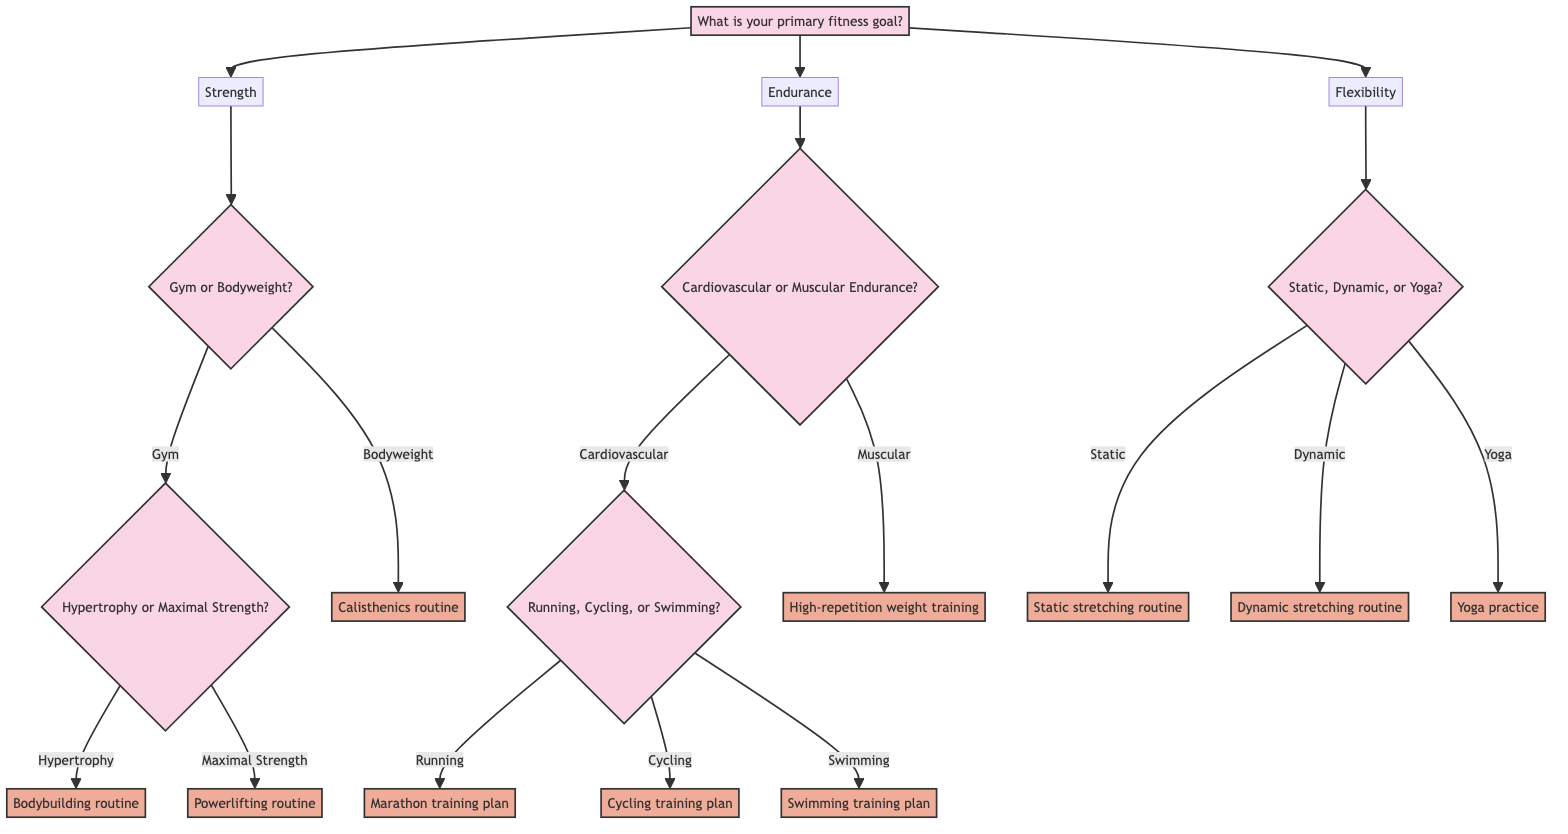What is the first question in the diagram? The first question in the diagram is presented at the root node, asking about the primary fitness goal of the individual.
Answer: What is your primary fitness goal? How many options are available after the first question? The first question branches into three options, which are Strength, Endurance, and Flexibility, totaling three options.
Answer: 3 What program is suggested for hypertrophy if the gym option is chosen? If the choice of gym is made and hypertrophy is selected as the focus, the program suggested is a bodybuilding routine.
Answer: Bodybuilding routine What type of endurance is a high-repetition weight training program associated with? High-repetition weight training is specifically associated with improving muscular endurance, as indicated in the diagram under the endurance section.
Answer: Muscular Endurance Which options do you have if you select the flexibility goal? Under the flexibility goal, there are three options to consider: Static Stretching, Dynamic Stretching, and Yoga, each leading to a different program.
Answer: Static Stretching, Dynamic Stretching, Yoga If a user prefers cycling, which training plan does the diagram recommend? If the user indicates a preference for cycling under cardiovascular endurance, the diagram recommends the Cycling training plan.
Answer: Cycling training plan What is the program associated with dynamic stretching? The program associated with dynamic stretching, as indicated in the flexibility section of the diagram, is the Dynamic stretching routine.
Answer: Dynamic stretching routine If you choose "Bodyweight" under Strength, what program comes next? Choosing "Bodyweight" under Strength leads directly to the recommendation of a Calisthenics routine without any further questions involved.
Answer: Calisthenics routine What do you need to consider next after specifying your fitness goal as cardiovascular endurance? After specifying cardiovascular endurance, the next consideration is which specific activity to pursue: Running, Cycling, or Swimming, as branching questions follow.
Answer: Running, Cycling, Swimming 